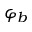Convert formula to latex. <formula><loc_0><loc_0><loc_500><loc_500>\varphi _ { b }</formula> 